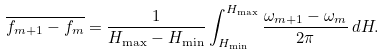Convert formula to latex. <formula><loc_0><loc_0><loc_500><loc_500>\overline { f _ { m + 1 } - f _ { m } } & = \frac { 1 } { H _ { \max } - H _ { \min } } \int _ { H _ { \min } } ^ { H _ { \max } } \frac { \omega _ { m + 1 } - \omega _ { m } } { 2 \pi } \, d H .</formula> 